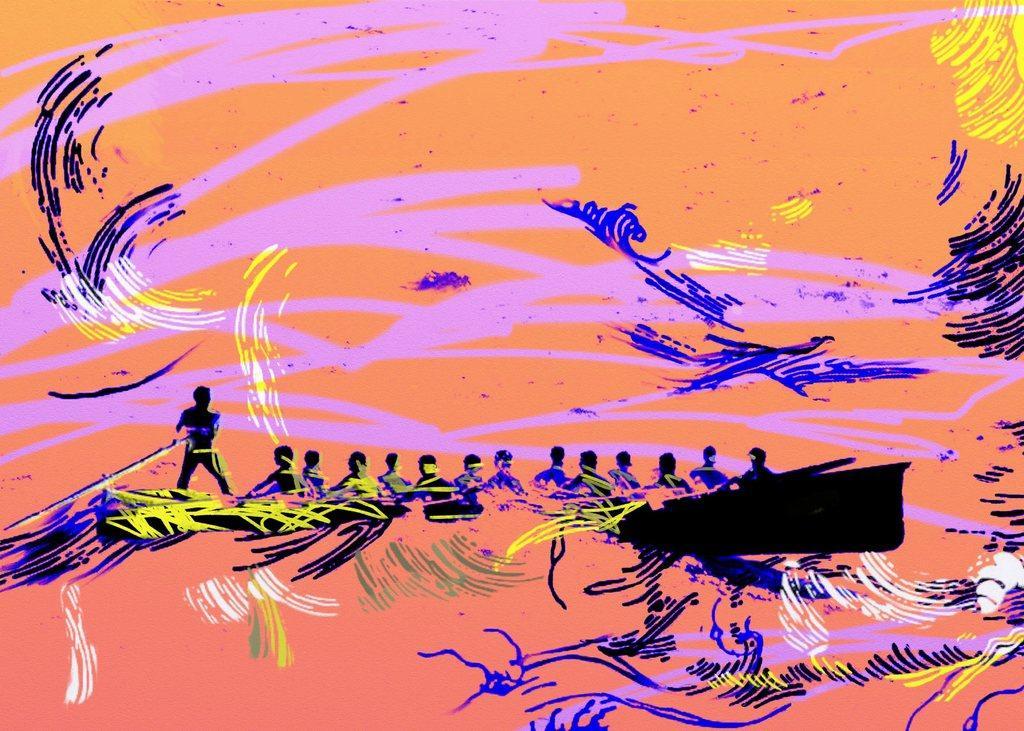Could you give a brief overview of what you see in this image? In the picture we can see a painting, in the painting we can see a boat with some people sitting and one man is standing and riding it with stick. 